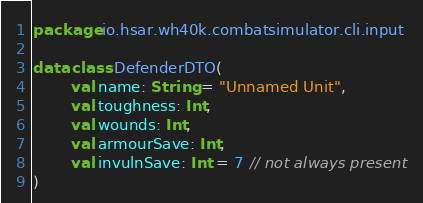Convert code to text. <code><loc_0><loc_0><loc_500><loc_500><_Kotlin_>package io.hsar.wh40k.combatsimulator.cli.input

data class DefenderDTO(
        val name: String = "Unnamed Unit",
        val toughness: Int,
        val wounds: Int,
        val armourSave: Int,
        val invulnSave: Int = 7 // not always present
)</code> 